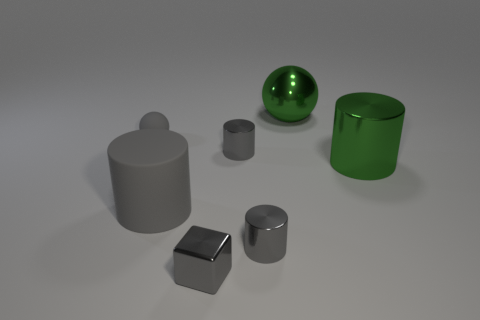Subtract all large metallic cylinders. How many cylinders are left? 3 Subtract all cyan cubes. How many gray cylinders are left? 3 Subtract all green cylinders. How many cylinders are left? 3 Add 1 big shiny cylinders. How many objects exist? 8 Subtract all cyan cylinders. Subtract all cyan spheres. How many cylinders are left? 4 Subtract all balls. How many objects are left? 5 Subtract all big purple cubes. Subtract all gray cubes. How many objects are left? 6 Add 1 tiny gray cylinders. How many tiny gray cylinders are left? 3 Add 7 small yellow cylinders. How many small yellow cylinders exist? 7 Subtract 0 purple balls. How many objects are left? 7 